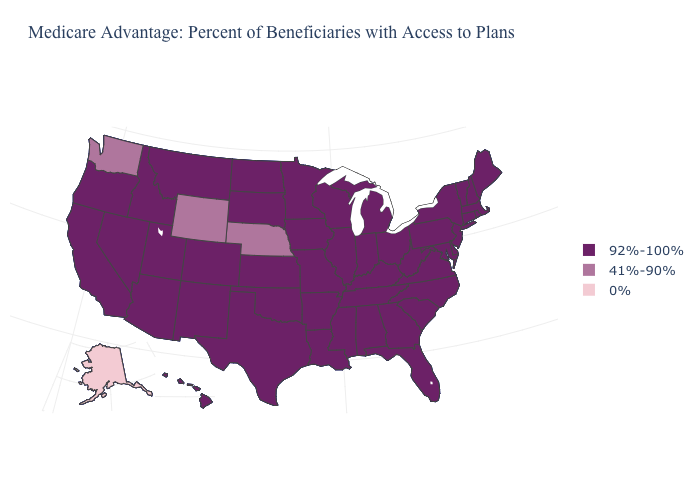Does Alaska have the lowest value in the USA?
Be succinct. Yes. Name the states that have a value in the range 0%?
Write a very short answer. Alaska. Name the states that have a value in the range 41%-90%?
Be succinct. Nebraska, Washington, Wyoming. What is the lowest value in states that border Maryland?
Keep it brief. 92%-100%. Name the states that have a value in the range 41%-90%?
Quick response, please. Nebraska, Washington, Wyoming. What is the value of Wisconsin?
Keep it brief. 92%-100%. Among the states that border Colorado , which have the lowest value?
Short answer required. Nebraska, Wyoming. Does West Virginia have the highest value in the USA?
Be succinct. Yes. Does Maryland have a lower value than Vermont?
Keep it brief. No. Does Oregon have the same value as Washington?
Answer briefly. No. What is the value of Wyoming?
Quick response, please. 41%-90%. Name the states that have a value in the range 41%-90%?
Give a very brief answer. Nebraska, Washington, Wyoming. How many symbols are there in the legend?
Keep it brief. 3. 